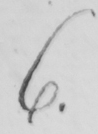Transcribe the text shown in this historical manuscript line. 6 . 